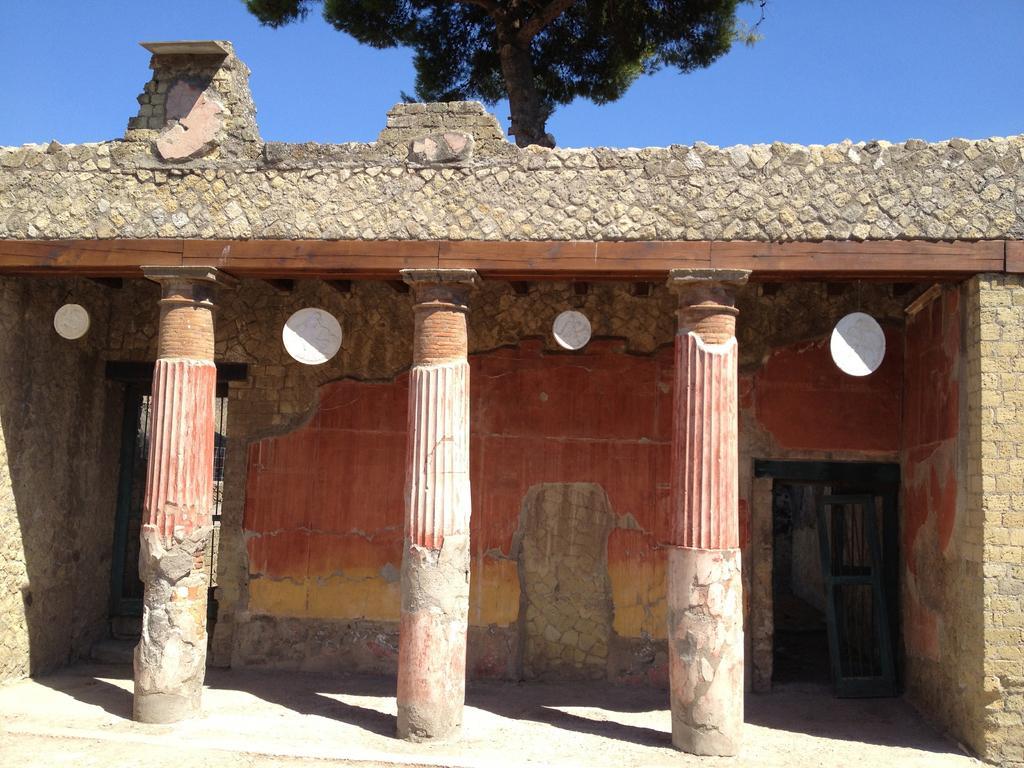In one or two sentences, can you explain what this image depicts? In the foreground of this image, there is an old building with three pillars, wall, and a door. In the background, we can see a tree and the sky. 